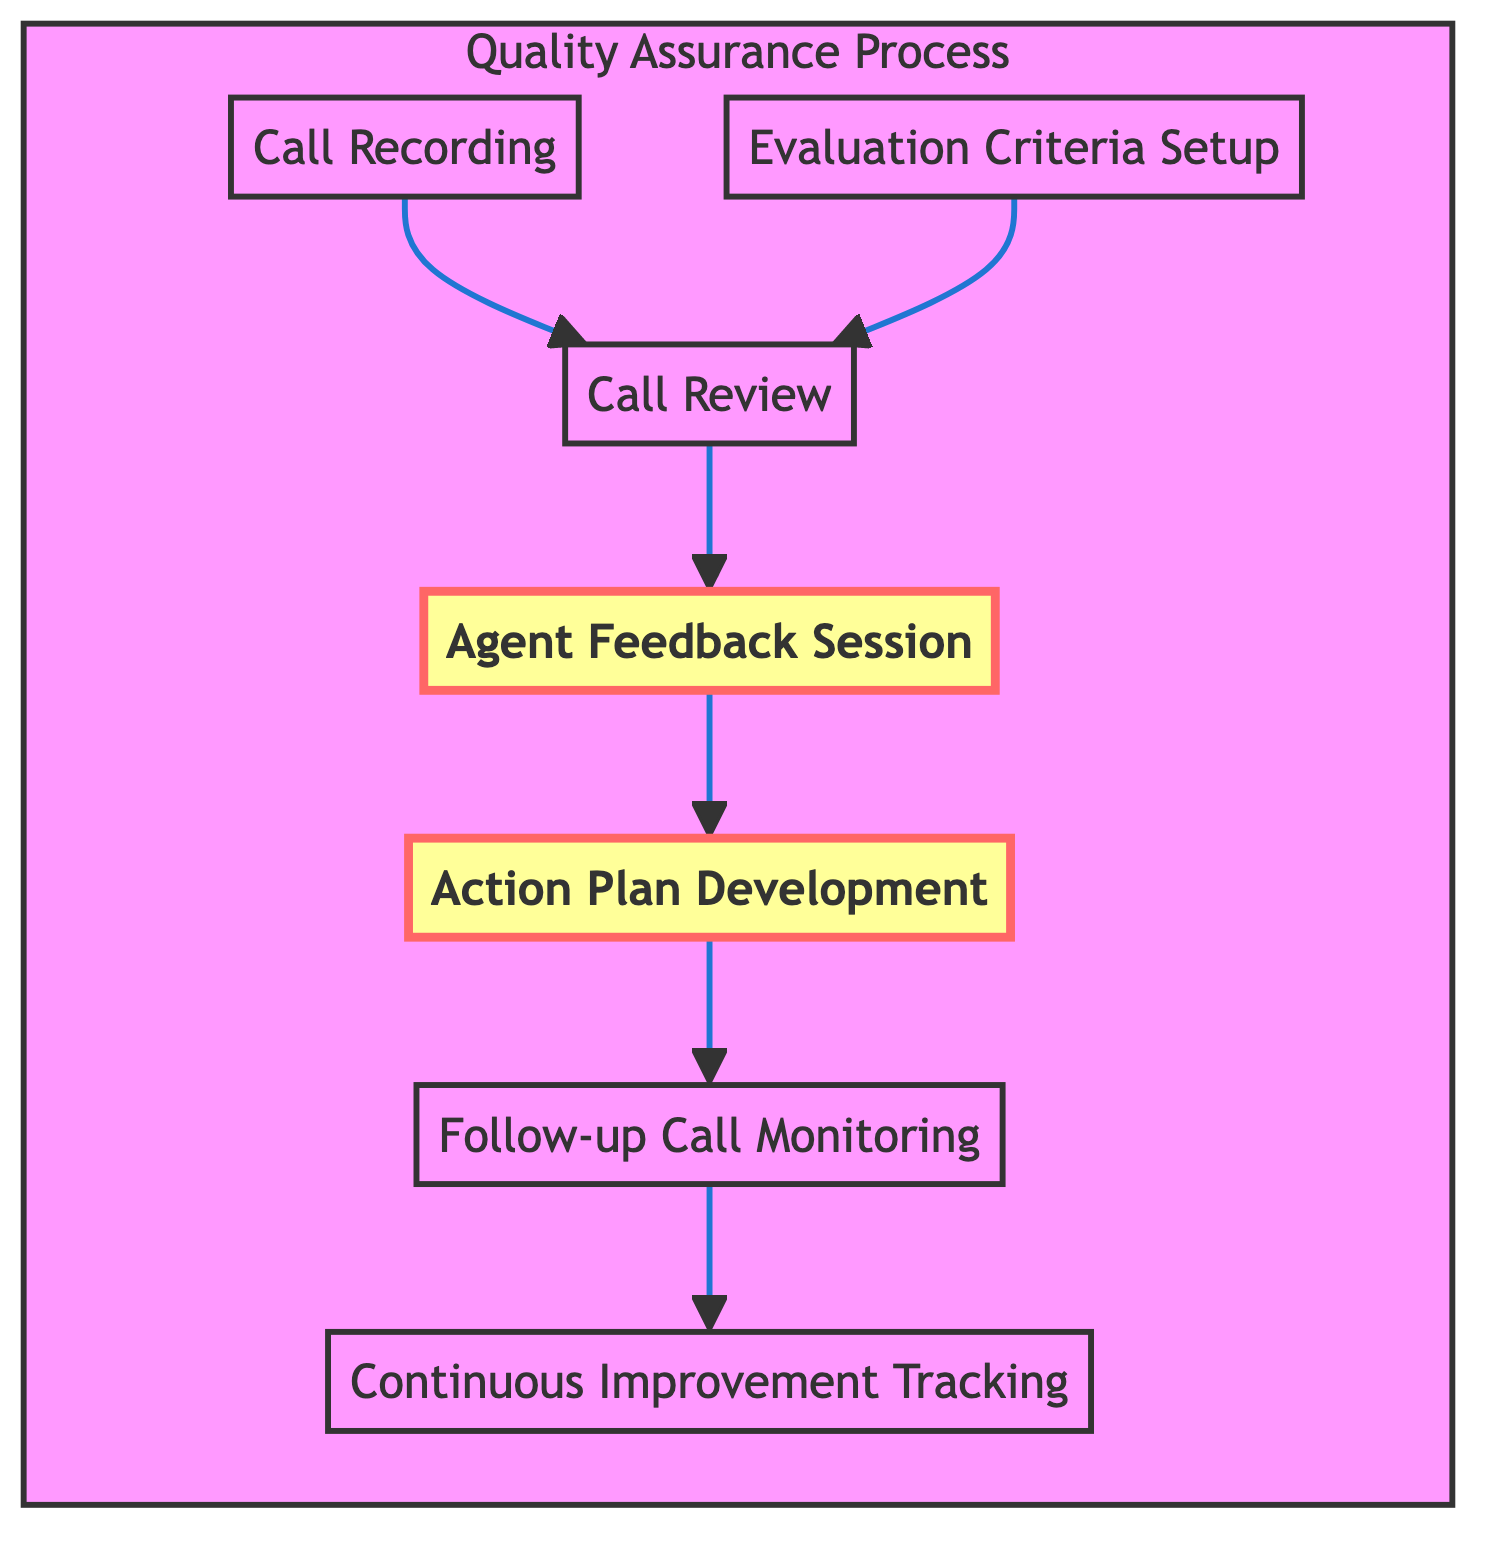What is the first step in the quality assurance process? The first step in the quality assurance process, as seen in the diagram, is "Call Recording." It is the initial node from which all other steps flow.
Answer: Call Recording How many steps are there in total? By counting each unique step present in the diagram, we see a total of seven distinct steps listed: Call Recording, Evaluation Criteria Setup, Call Review, Agent Feedback Session, Action Plan Development, Follow-up Call Monitoring, and Continuous Improvement Tracking.
Answer: Seven Which step directly follows the Call Review? According to the flow of the diagram, after the "Call Review" step, the next step is "Agent Feedback Session." This is indicated by the arrow connecting the two steps.
Answer: Agent Feedback Session What is the purpose of the Action Plan Development step? The diagram provides a description for the Action Plan Development step, indicating its purpose is to create an improvement plan for agents who need additional support after their evaluations.
Answer: Create an improvement plan for agents needing additional support Which steps are highlighted in the diagram? There are two highlighted steps in the diagram: "Agent Feedback Session" and "Action Plan Development." These are visually distinct from the others, indicating a specific focus on these steps.
Answer: Agent Feedback Session, Action Plan Development What happens after the Follow-up Call Monitoring? Following the "Follow-up Call Monitoring" step, the next step in the flow continues to "Continuous Improvement Tracking." This indicates the ongoing nature of quality assurance processes.
Answer: Continuous Improvement Tracking How do Evaluation Criteria Setup and Call Recording relate to Call Review? Both the "Evaluation Criteria Setup" and "Call Recording" steps are prerequisites for the "Call Review" step. They provide necessary information and context for the evaluation process, as indicated by the arrows leading into Call Review.
Answer: They lead into Call Review as prerequisites What type of process is described in the diagram? The diagram describes a quality assurance process, which involves multiple steps focused on evaluating and improving call interactions in a call center environment.
Answer: Quality assurance process 